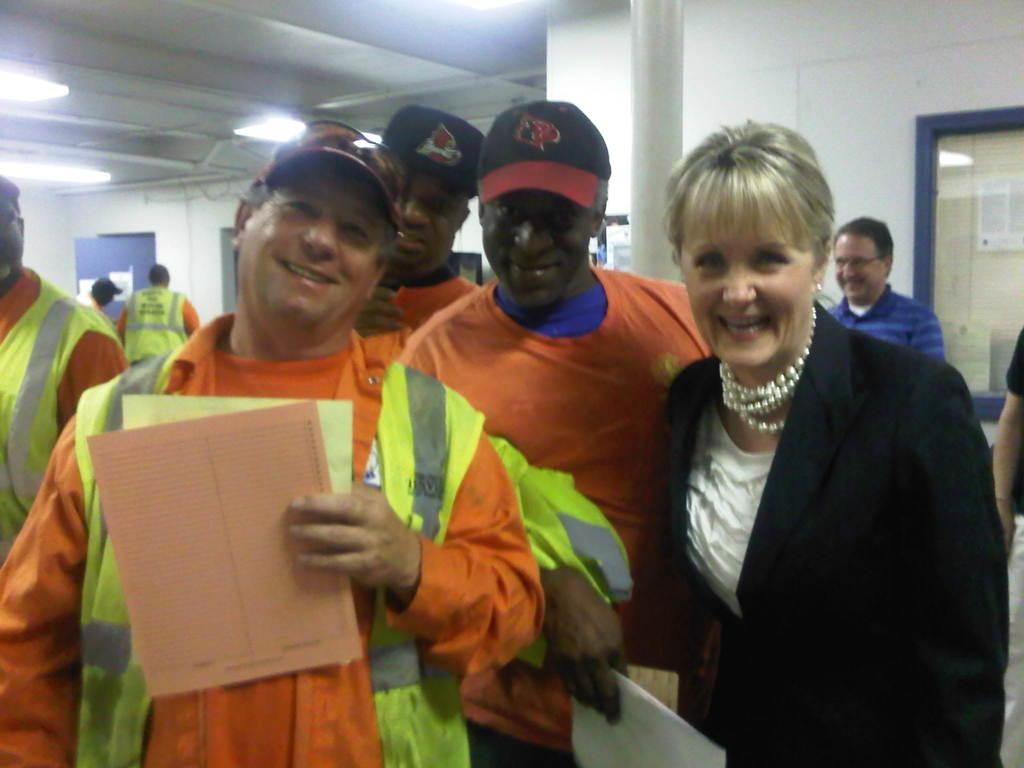How many people are present in the image? There are people in the image, but the exact number is not specified. What are the two men holding in the image? The two men are holding papers in the image. What can be seen in the background of the image? There is a wall, a pillar, boards, and lights in the background of the image. What color is the class in the image? There is no class present in the image, so it is not possible to determine its color. 